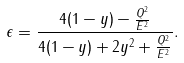Convert formula to latex. <formula><loc_0><loc_0><loc_500><loc_500>\epsilon = \frac { 4 ( 1 - y ) - \frac { Q ^ { 2 } } { E ^ { 2 } } } { 4 ( 1 - y ) + 2 y ^ { 2 } + \frac { Q ^ { 2 } } { E ^ { 2 } } } .</formula> 